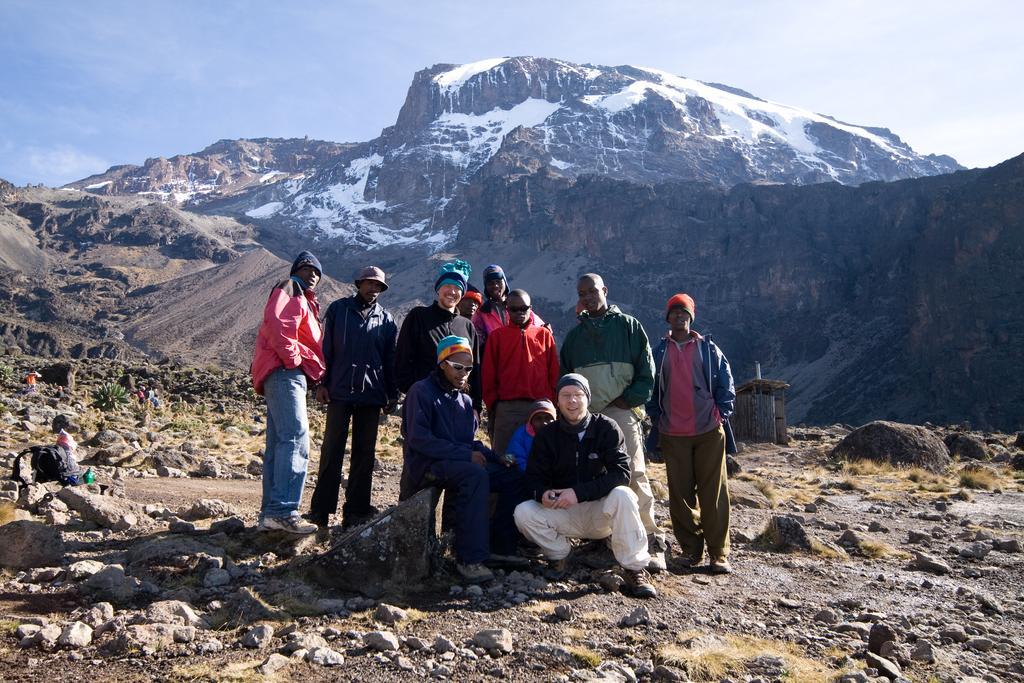Can you describe this image briefly? In this image I can see a group of people. In the background, I can see the hills with the snow. At the top I can see the clouds in the sky. 